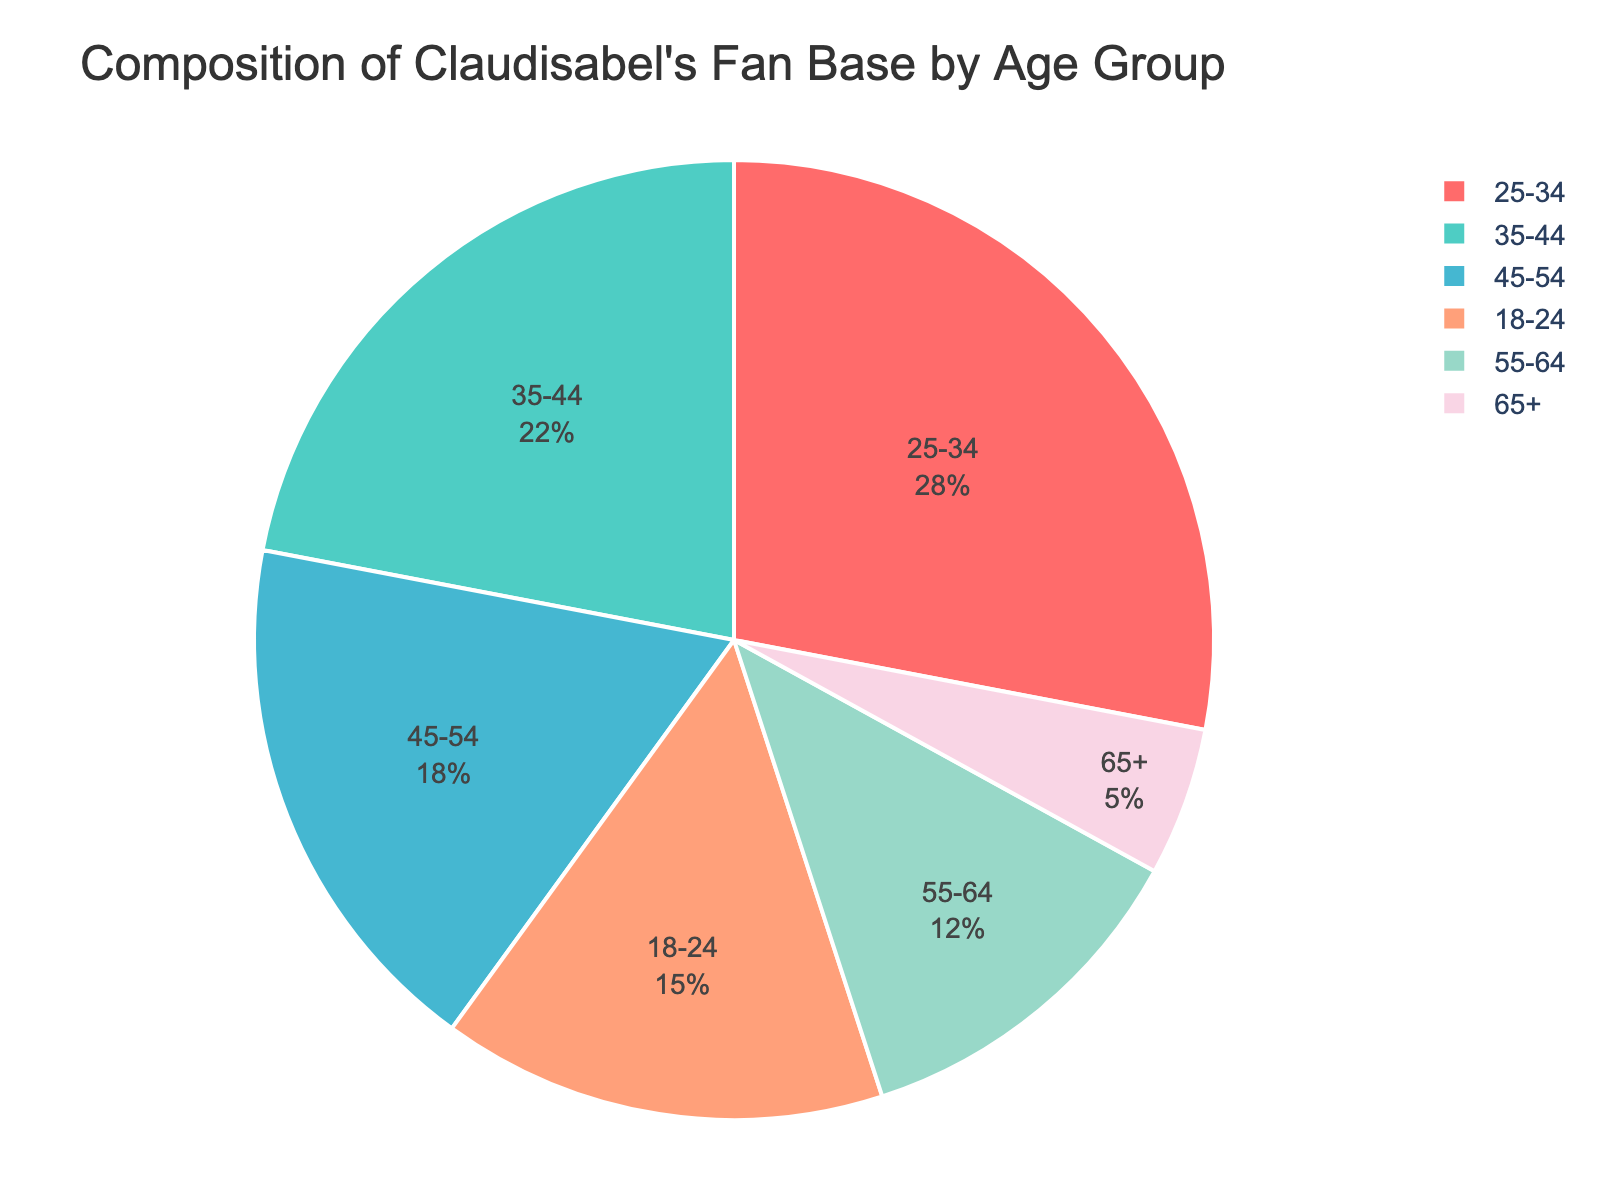What is the largest age group among Claudisabel's fan base? The pie chart shows the fans' age groups with percentages. The largest slice represents the 25-34 age group with 28%.
Answer: 25-34 Which age group has the smallest percentage of Claudisabel's fans? The smallest slice in the pie chart corresponds to the 65+ age group with 5%.
Answer: 65+ What is the combined percentage of fans aged 35-44 and 45-54? Add the percentage of the 35-44 age group (22%) and the 45-54 age group (18%). 22% + 18% = 40%.
Answer: 40% How much larger is the fan base percentage of the 25-34 age group compared to the 55-64 age group? Subtract the percentage of the 55-64 age group (12%) from the 25-34 age group (28%). 28% - 12% = 16%.
Answer: 16% Identify two age groups whose combined fan base percentage equals that of the 25-34 age group. The 18-24 age group (15%) and the 55-64 age group (12%) sum up to 27%, which is closest but doesn't match. The 35-44 age group (22%) and the 45-54 age group (18%) sum up to 40%, which also doesn't match. There's no exact pair combination that adds up precisely to 28%. The answer is none.
Answer: None Which color represents the 18-24 age group in the pie chart? The custom color palette assigns the first color to the first category listed. Therefore, the 18-24 age group is represented by red.
Answer: Red What is the difference in fan base percentage between the 45-54 and 18-24 age groups? Subtract the percentage of the 18-24 age group (15%) from the 45-54 age group (18%). 18% - 15% = 3%.
Answer: 3% Which two age groups have a combined fan base percentage of 30%? Adding the percentages, 18-24 (15%) + 55-64 (12%) = 27%, which is closest but does not match. The exact combination cannot be found within the given data.
Answer: None How does the percentage of the 25-34 age group compare to the 35-44 age group? The pie chart shows that the 25-34 age group has a larger percentage (28%) than the 35-44 age group (22%).
Answer: Larger What percentage of Claudisabel's fan base is aged 45 and above? Sum the percentages of the age groups 45-54, 55-64, and 65+: 18% + 12% + 5% = 35%.
Answer: 35% 